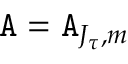Convert formula to latex. <formula><loc_0><loc_0><loc_500><loc_500>A = A _ { J _ { \tau } , m }</formula> 